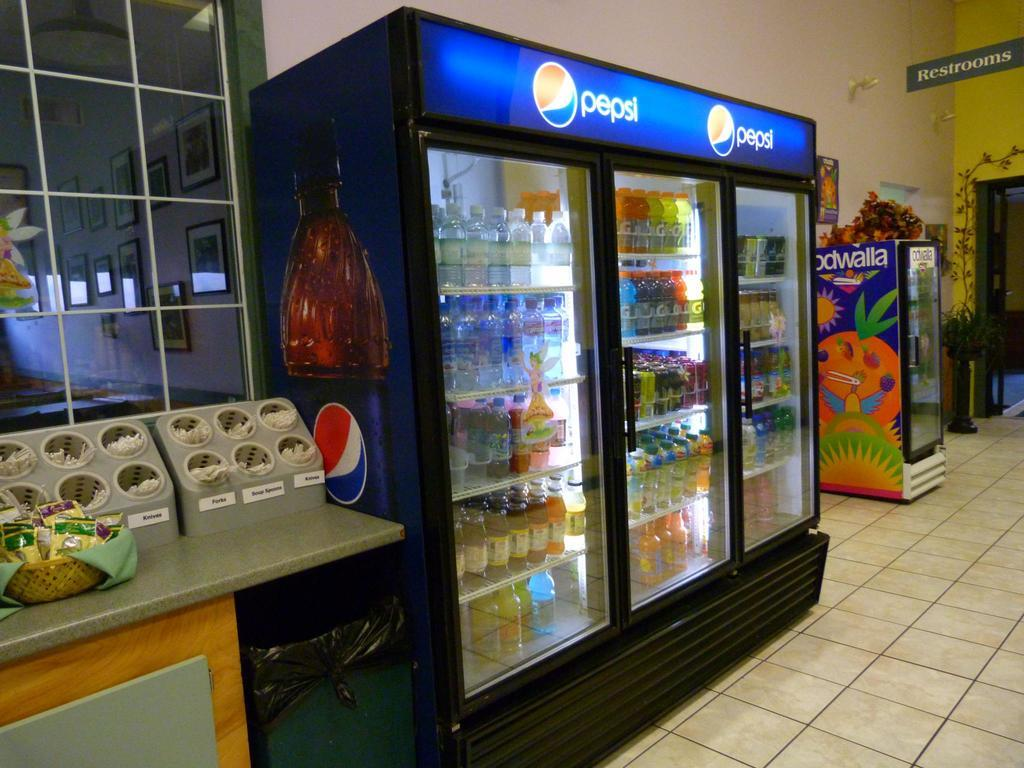What large appliance can be seen in the image? There is a big fridge in the image. What is stored inside the fridge? The fridge contains many bottles. What else is present in the image besides the fridge? There is a table with food stuff in the image. What is placed on top of the table? There is a restroom board on the top of the table. Are there any pets visible in the image? No, there are no pets present in the image. Can you tell me what type of library is shown in the image? There is no library present in the image; it features a fridge, table, and restroom board. 